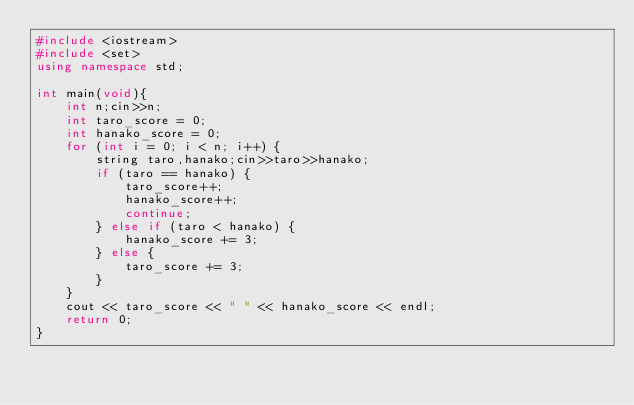Convert code to text. <code><loc_0><loc_0><loc_500><loc_500><_C++_>#include <iostream>
#include <set>
using namespace std;

int main(void){
    int n;cin>>n;
    int taro_score = 0;
    int hanako_score = 0;
    for (int i = 0; i < n; i++) {
        string taro,hanako;cin>>taro>>hanako;
        if (taro == hanako) {
            taro_score++;
            hanako_score++;
            continue;
        } else if (taro < hanako) {
            hanako_score += 3;
        } else {
            taro_score += 3;
        }
    }
    cout << taro_score << " " << hanako_score << endl;
    return 0;
}
</code> 